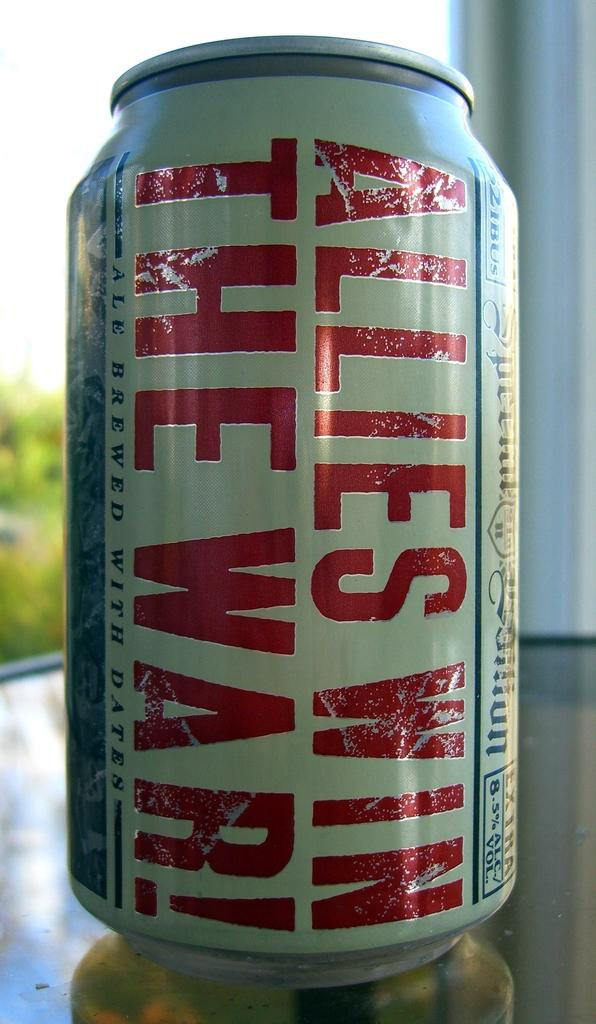Provide a one-sentence caption for the provided image. The beer can has the slogan "Allies Win the War!". 